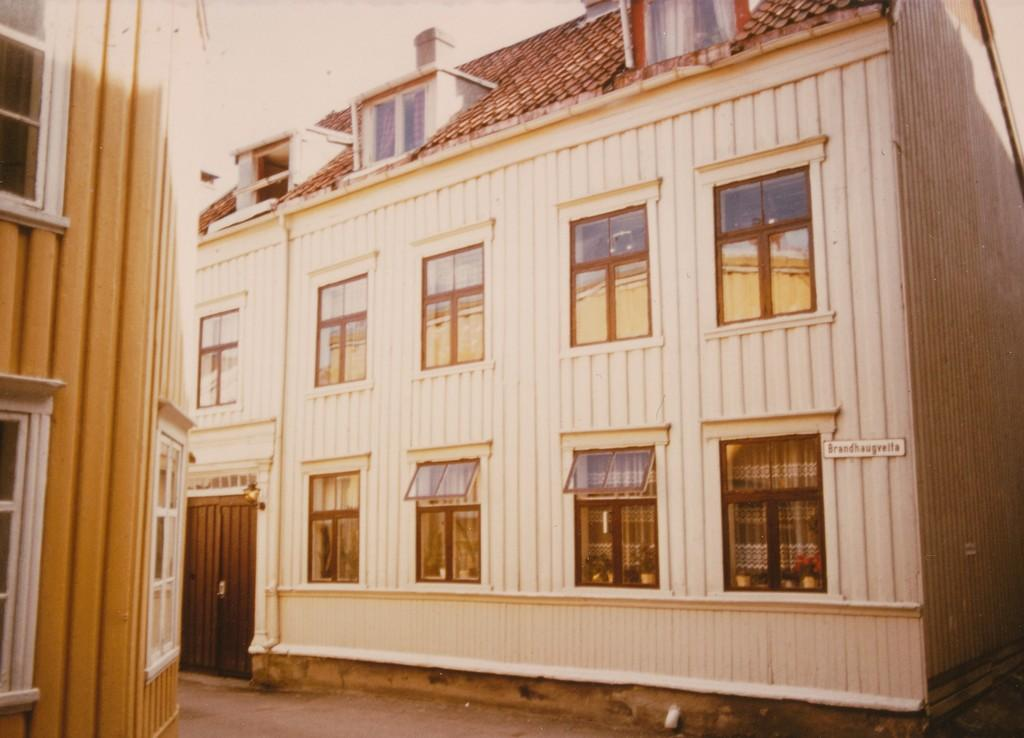What type of structures are present in the image? There are buildings in the image. What features can be seen on the buildings? The buildings have windows and doors. Is there any additional information about one of the buildings? Yes, there is a board on one of the buildings. How many beds can be seen in the image? There are no beds present in the image. Is there a boot visible on any of the buildings? No, there is no boot visible on any of the buildings in the image. 